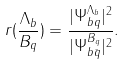Convert formula to latex. <formula><loc_0><loc_0><loc_500><loc_500>r ( \frac { \Lambda _ { b } } { B _ { q } } ) = \frac { | \Psi _ { b q } ^ { \Lambda _ { b } } | ^ { 2 } } { | \Psi _ { b \bar { q } } ^ { B _ { q } } | ^ { 2 } } .</formula> 